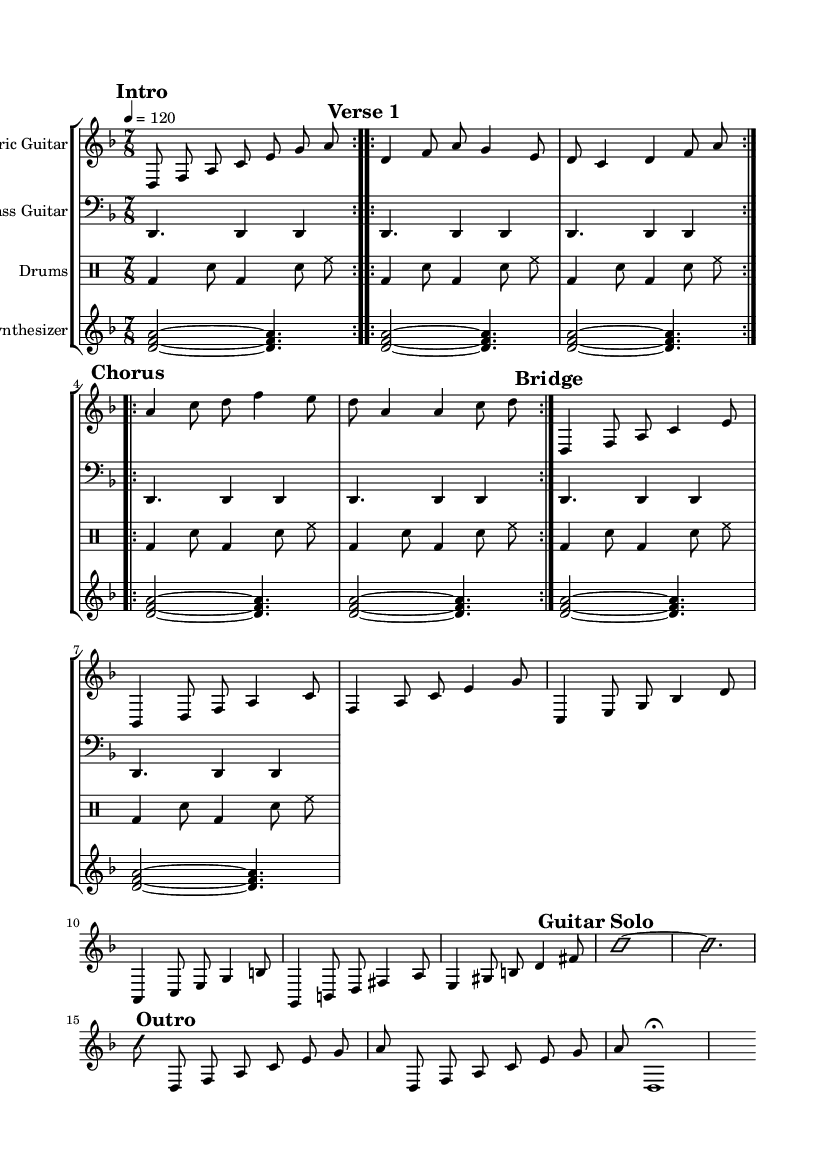What is the key signature of this music? The key signature is D minor, which consists of one flat (B flat). This can be identified at the beginning of the music sheet next to the clef.
Answer: D minor What is the time signature of this music? The time signature is 7/8, which indicates there are 7 eighth notes in each measure. This is visible in the beginning of the music where the time signature appears.
Answer: 7/8 What is the tempo indication given in the music? The tempo is marked at 4 equal to 120, meaning there should be 120 quarter note beats per minute. This is specified in the tempo marking at the beginning of the piece.
Answer: 120 How many sections are designated in the structure of the music? The music contains five main sections: Intro, Verse 1, Chorus, Bridge, and Outro. These sections are labeled throughout the score, indicating the organization of the piece.
Answer: Five What type of mode is primarily used for the improvisation section? The improvisation section utilizes D minor for soloing, as indicated by the overall key signature of the piece. This ties into the music's harmonic framework throughout.
Answer: D minor How many repeats are indicated for the Chorus section? The Chorus section has two repeats indicated as stated in the markings at the beginning of that section. This suggests it is to be played twice before moving on.
Answer: Two 